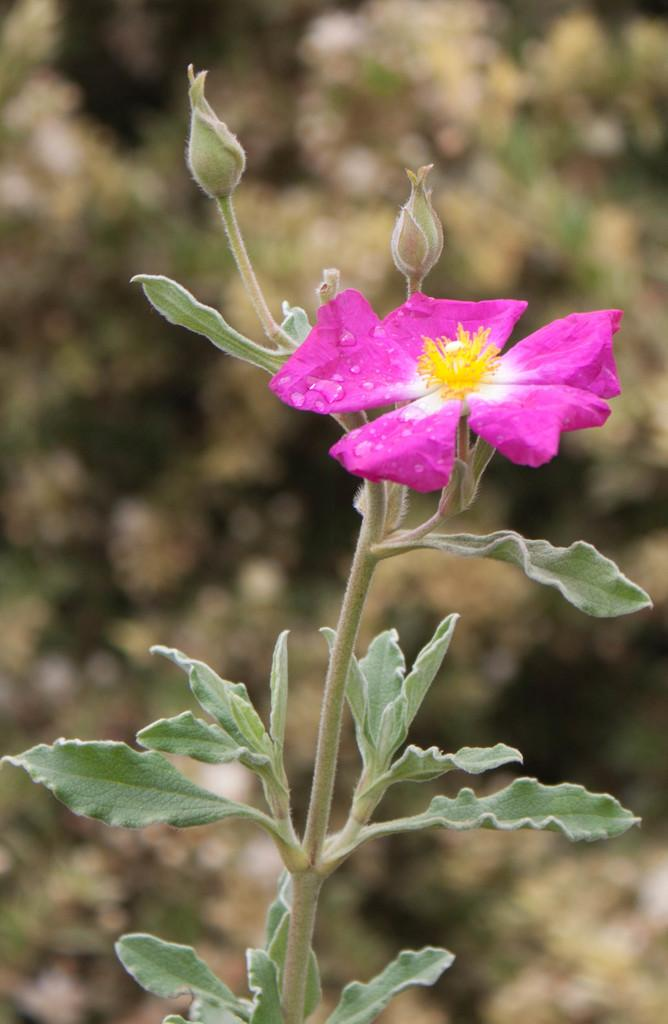What is located in the foreground of the picture? There is a plant in the foreground of the picture. What stage of growth are the plant's buds in? The plant has buds, which suggests they are in the process of developing. What is the most prominent feature of the plant? The plant has a flower. How would you describe the background of the image? The background of the image is blurred. What type of organization is responsible for the ball in the image? There is no ball present in the image, so it is not possible to determine which organization might be responsible for it. 